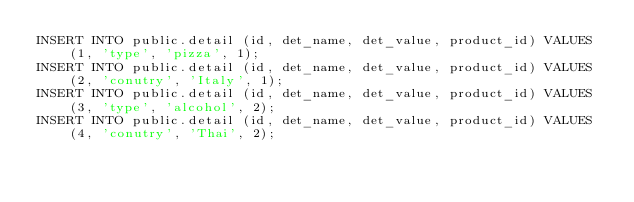Convert code to text. <code><loc_0><loc_0><loc_500><loc_500><_SQL_>INSERT INTO public.detail (id, det_name, det_value, product_id) VALUES (1, 'type', 'pizza', 1);
INSERT INTO public.detail (id, det_name, det_value, product_id) VALUES (2, 'conutry', 'Italy', 1);
INSERT INTO public.detail (id, det_name, det_value, product_id) VALUES (3, 'type', 'alcohol', 2);
INSERT INTO public.detail (id, det_name, det_value, product_id) VALUES (4, 'conutry', 'Thai', 2);</code> 